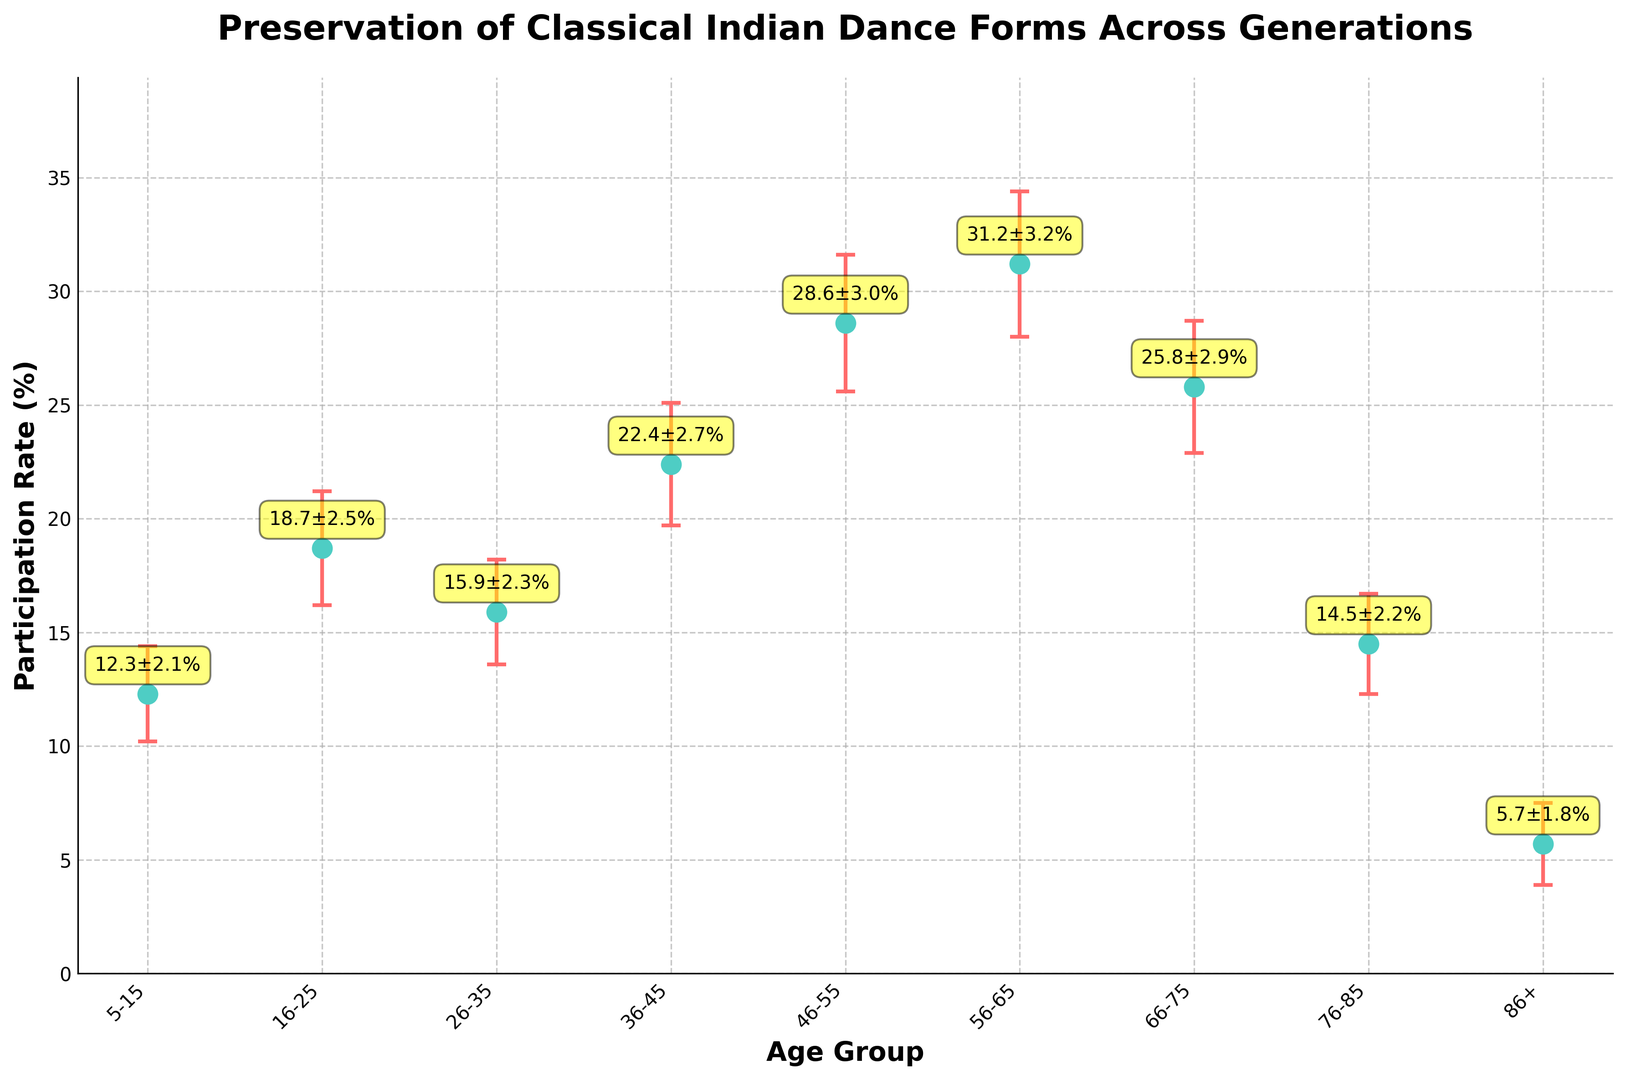What's the participation rate in the 56-65 age group? Look at the data point for the 56-65 age group. The participation rate is marked and can also be seen as an annotation.
Answer: 31.2% Which age group has the highest participation rate? Look for the highest point on the chart. The highest participation rate is for the 56-65 age group.
Answer: 56-65 What is the difference in participation rates between the 36-45 and 66-75 age groups? Locate the participation rates for both age groups: 22.4% for 36-45 and 25.8% for 66-75. Subtract the smaller rate from the larger rate: 25.8 - 22.4 = 3.4%.
Answer: 3.4% Which age group has the smallest error margin? Look for the smallest error bar. The smallest error margin is for the 86+ age group with 1.8%.
Answer: 86+ How does the participation rate of the 5-15 age group compare to the 76-85 age group? Locate the participation rates: 12.3% for 5-15 and 14.5% for 76-85. The 76-85 age group has a higher participation rate.
Answer: The 76-85 age group has a higher rate What is the average participation rate across all age groups? Add all participation rates and divide by the number of groups: (12.3 + 18.7 + 15.9 + 22.4 + 28.6 + 31.2 + 25.8 + 14.5 + 5.7)/9. Sum is 175.1, average is 175.1/9 ≈ 19.46%.
Answer: 19.46% What is the participation rate for the age group with an error margin of 3.0%? Find the data point with a 3.0% error margin. The participation rate for the 46-55 age group is 28.6%.
Answer: 28.6% Compare the participation rates of the 26-35 and 36-45 age groups and state which one is higher. Check the values: 15.9% for 26-35 and 22.4% for 36-45. The 36-45 age group has a higher participation rate.
Answer: The 36-45 age group has a higher rate Which age group shows the lowest participation rate in classical Indian dance forms? Identify the lowest point on the chart. The lowest participation rate is for the 86+ age group with 5.7%.
Answer: 86+ Calculate the total error margin summing up all age groups. Add all error margins: 2.1 + 2.5 + 2.3 + 2.7 + 3.0 + 3.2 + 2.9 + 2.2 + 1.8. Sum is 22.6%.
Answer: 22.6% 